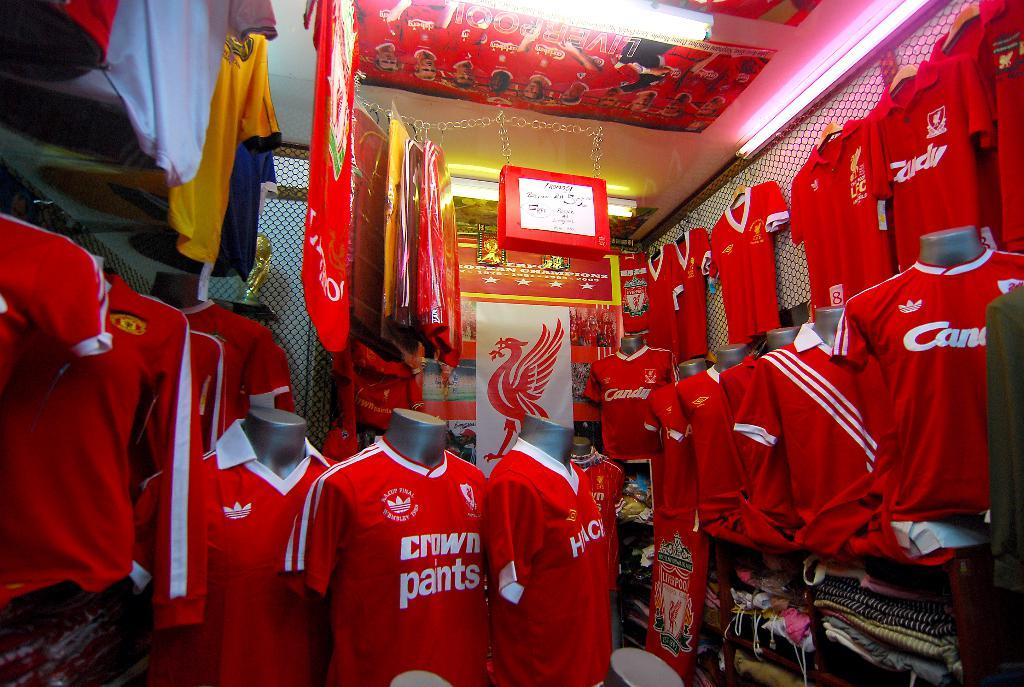<image>
Provide a brief description of the given image. A room full of red shirts, one which says "crown pants". 